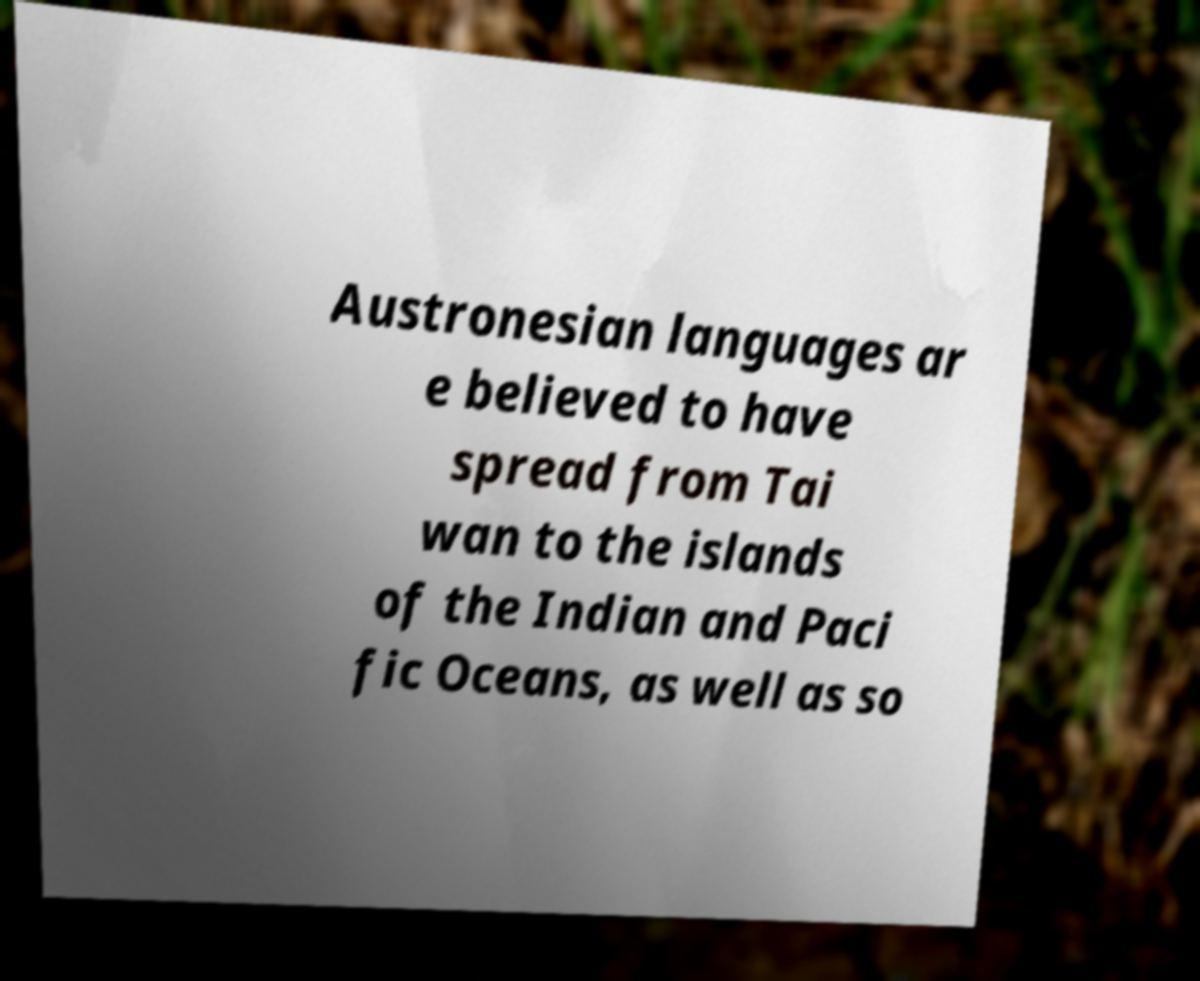Can you accurately transcribe the text from the provided image for me? Austronesian languages ar e believed to have spread from Tai wan to the islands of the Indian and Paci fic Oceans, as well as so 